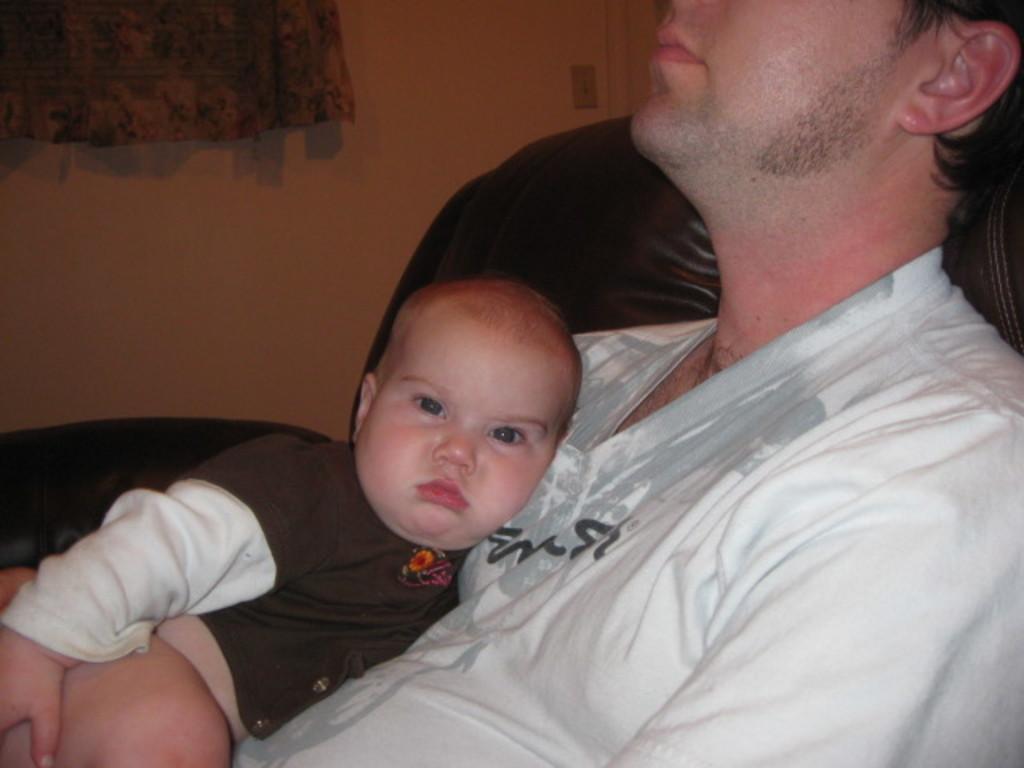Please provide a concise description of this image. In this image I can see a person wearing white colored dress is sitting on the couch which is black in color and I can see a baby on the person. In the background I can see the wall and the curtain. 